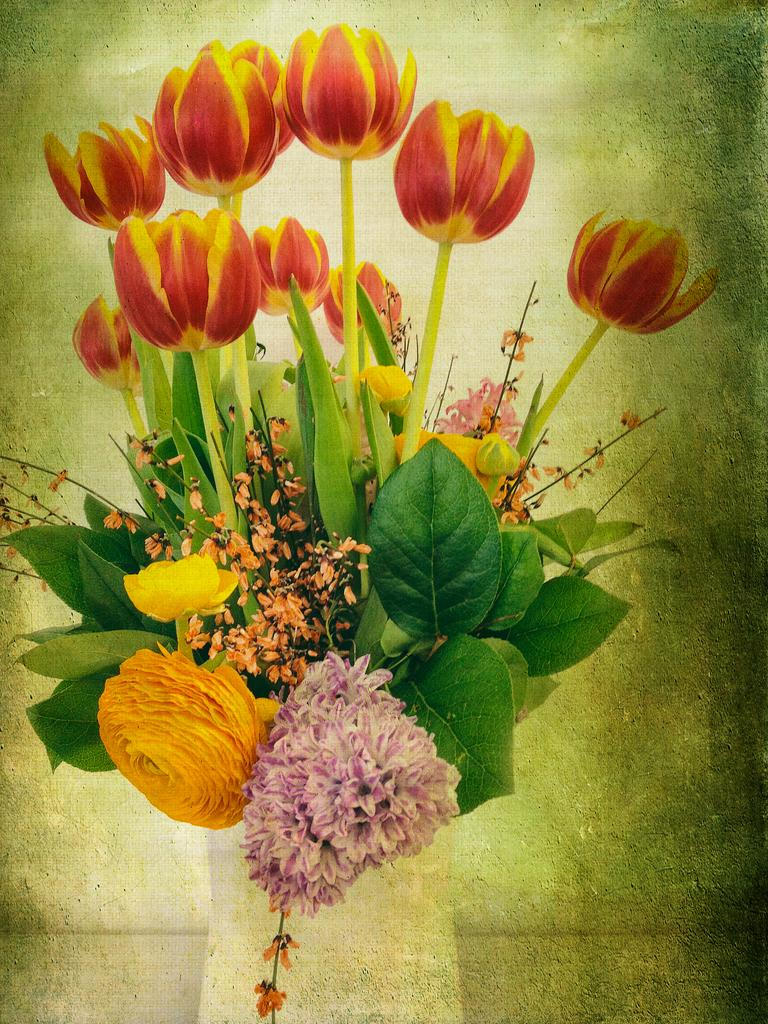What is the main subject of the painting in the image? The painting depicts a flower vase. How many flowers are in the vase? The flower vase has many flowers. Are there any other elements in the painting besides the flowers? Yes, the flower vase has leaves. What color is the background of the painting? The background of the painting is green. What type of zinc object can be seen in the painting? There is no zinc object present in the painting; it features a flower vase with flowers and leaves. How many eggs are visible in the painting? There are no eggs present in the painting; it features a flower vase with flowers and leaves. 